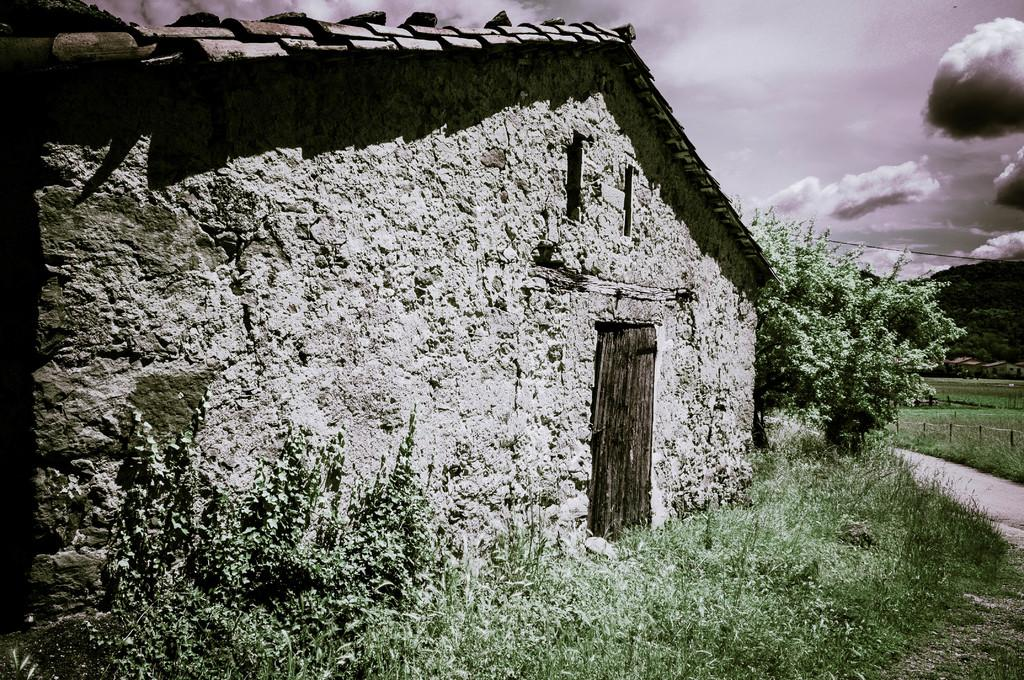What type of structure is present in the image? There is a building in the image. What feature of the building is mentioned in the facts? The building has a door. What can be seen on the right side of the image? There is a tree on the right side of the image. What is visible in the background of the image? The sky is visible in the background of the image. How would you describe the sky in the image? The sky appears to be cloudy. What advice does the pig give to the steam in the image? There is no pig or steam present in the image, so no such interaction can be observed. 